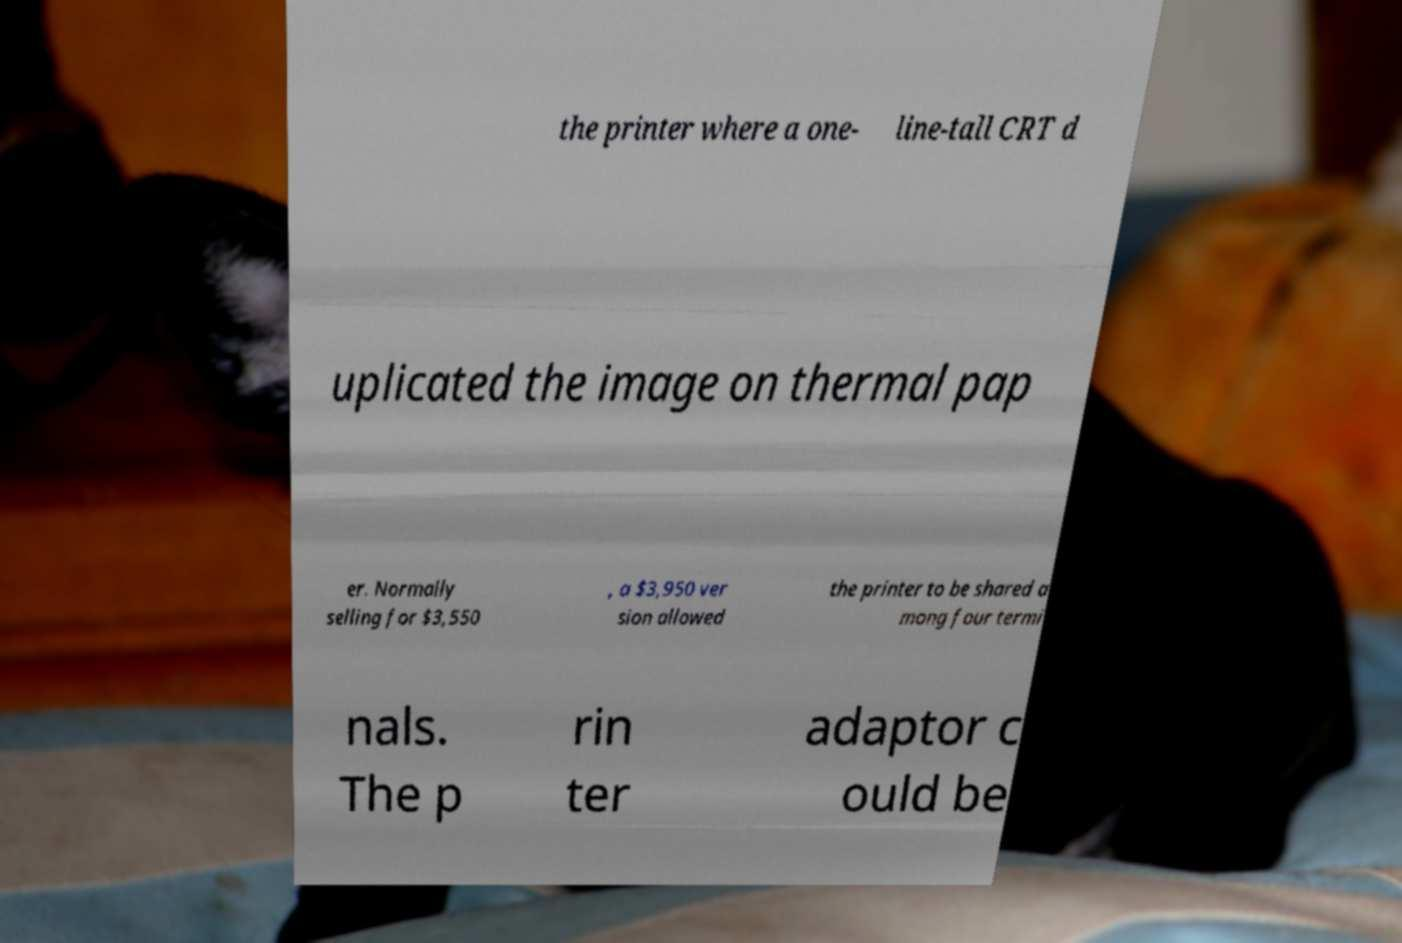For documentation purposes, I need the text within this image transcribed. Could you provide that? the printer where a one- line-tall CRT d uplicated the image on thermal pap er. Normally selling for $3,550 , a $3,950 ver sion allowed the printer to be shared a mong four termi nals. The p rin ter adaptor c ould be 